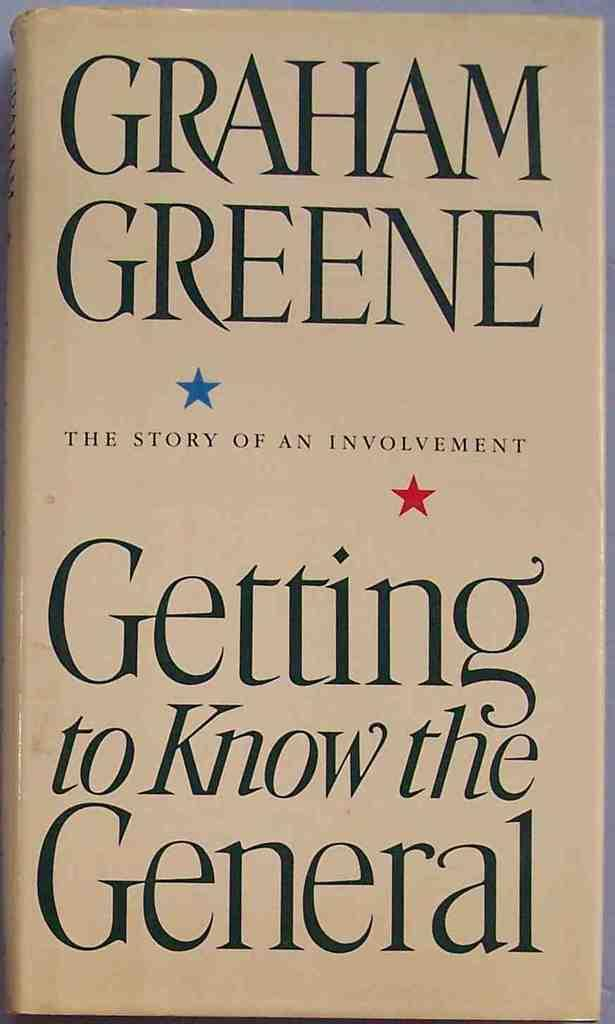<image>
Summarize the visual content of the image. Graham Greene wrote Getting to Know the General, which has two small stars on the cover. 